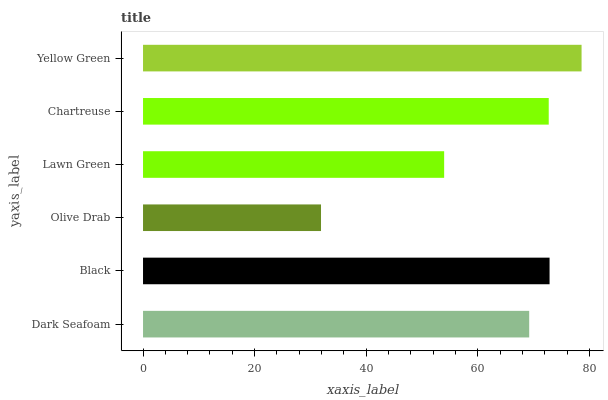Is Olive Drab the minimum?
Answer yes or no. Yes. Is Yellow Green the maximum?
Answer yes or no. Yes. Is Black the minimum?
Answer yes or no. No. Is Black the maximum?
Answer yes or no. No. Is Black greater than Dark Seafoam?
Answer yes or no. Yes. Is Dark Seafoam less than Black?
Answer yes or no. Yes. Is Dark Seafoam greater than Black?
Answer yes or no. No. Is Black less than Dark Seafoam?
Answer yes or no. No. Is Chartreuse the high median?
Answer yes or no. Yes. Is Dark Seafoam the low median?
Answer yes or no. Yes. Is Yellow Green the high median?
Answer yes or no. No. Is Black the low median?
Answer yes or no. No. 